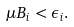Convert formula to latex. <formula><loc_0><loc_0><loc_500><loc_500>\mu B _ { i } < \epsilon _ { i } .</formula> 